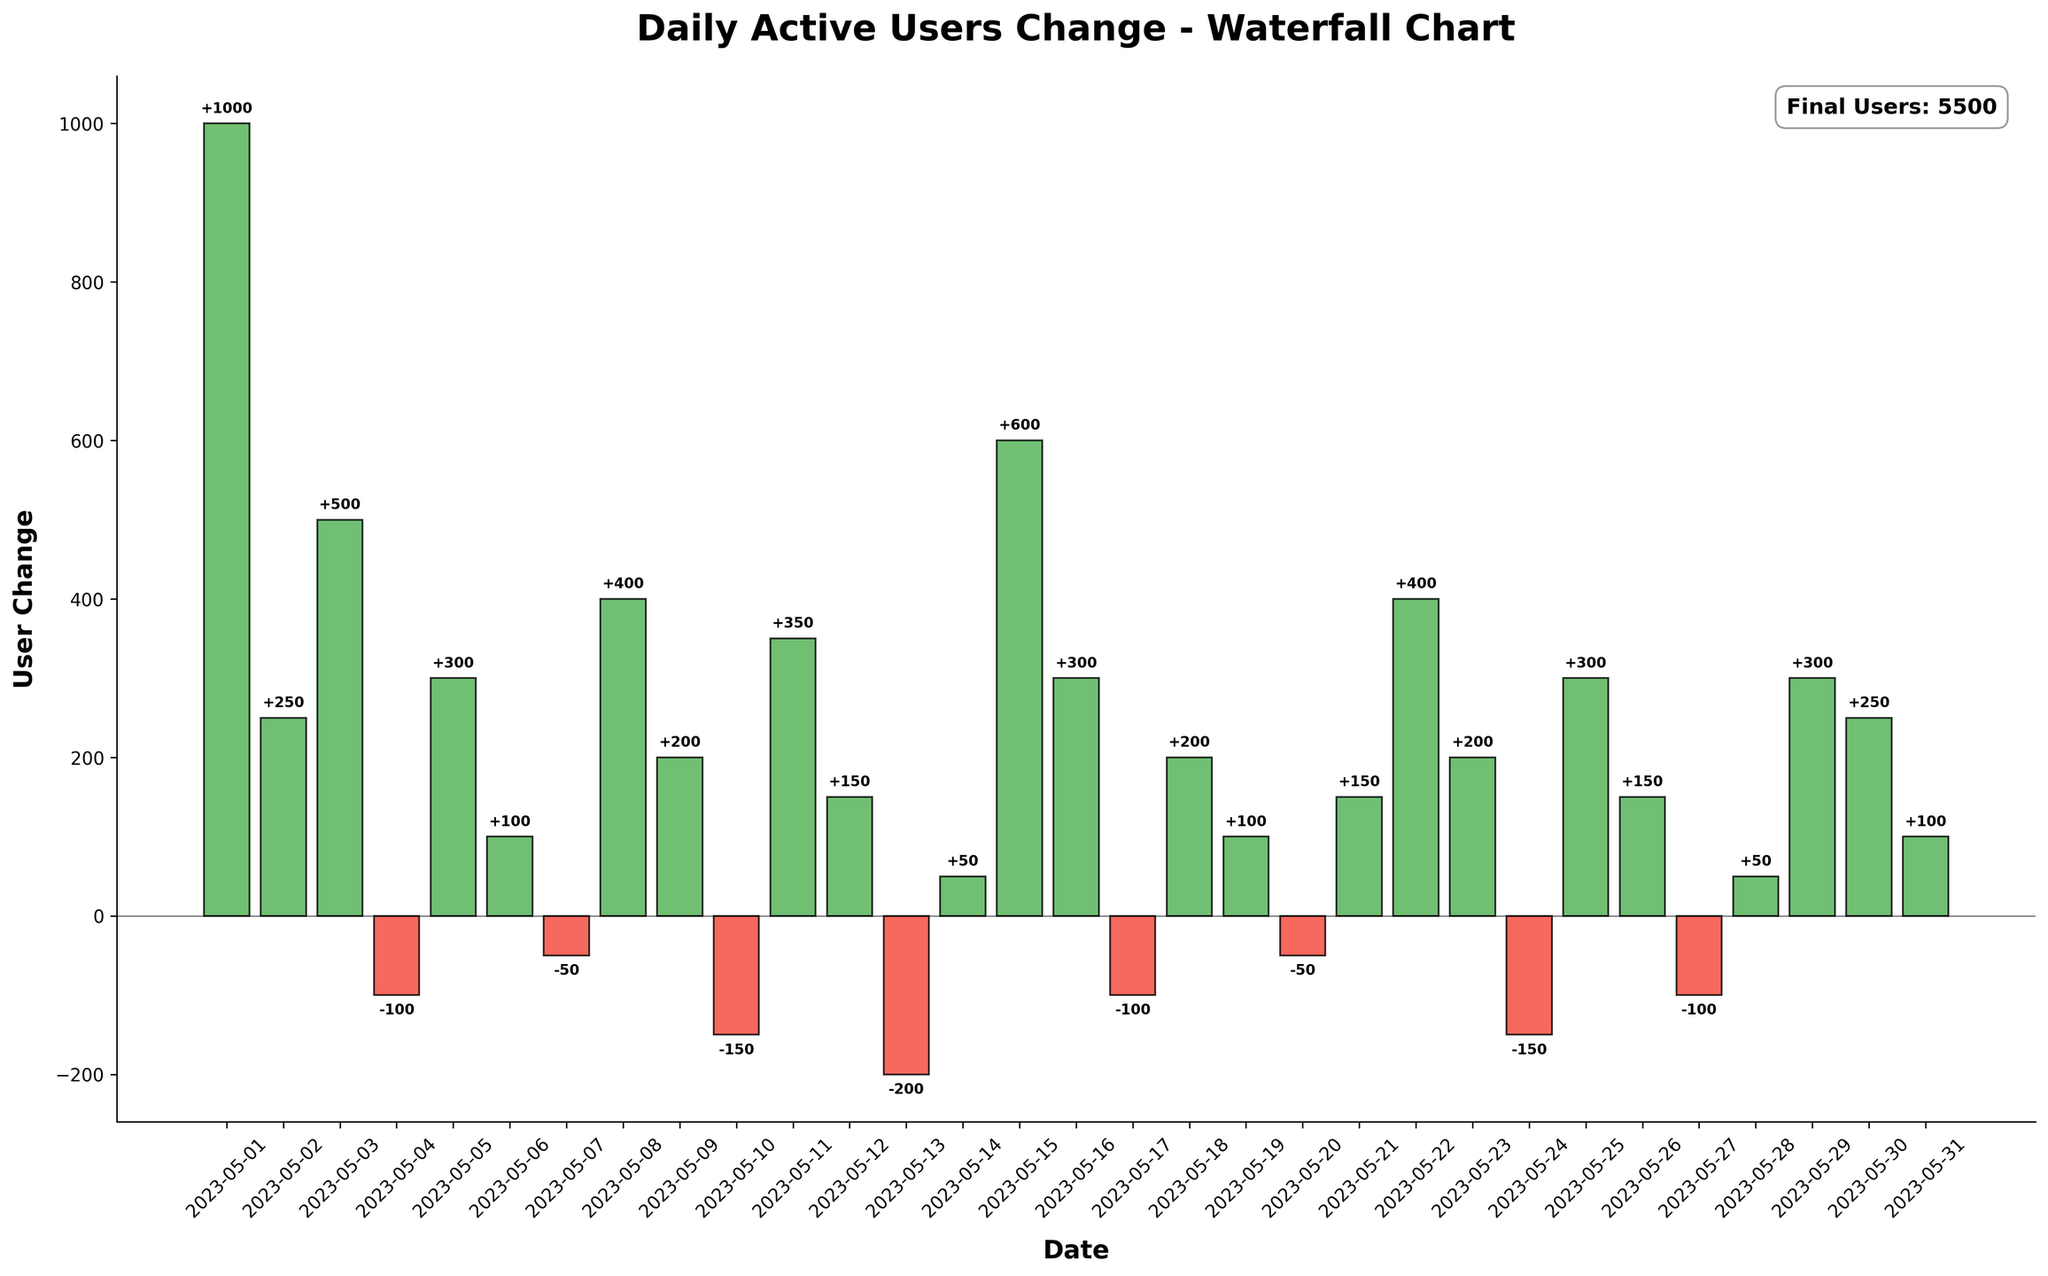what is the title of the figure? The title of the figure is positioned at the top of the chart in large, bold font.
Answer: Daily Active Users Change - Waterfall Chart What is the total number of data points shown in the chart? Count the number of bars present in the chart, one for each day. There are 31 days shown, so 31 data points.
Answer: 31 On which date was there the highest user increase, and what was the value? Scan through the values presented above each positive bar for each date and identify the highest one. The highest positive change occurred on May 15 with an increase of 600 users.
Answer: May 15, +600 How many days had a decrease in daily active users? Count the bars with negative values (displayed in red). There are 7 days with a negative user change: May 4, May 7, May 10, May 13, May 17, May 20, May 24, and May 27.
Answer: 7 What’s the cumulative number of users on the last day represented in the chart? Look at the top-right annotation which indicates the final number of users.
Answer: 5500 What is the combined user change over the first week? Sum the daily user changes from May 1 to May 7: 1000 + 250 + 500 - 100 + 300 + 100 - 50 = 2000 users.
Answer: 2000 What is the average daily user change for the month? Sum all the daily changes and divide by the number of days (31). The sum of changes is 1000 + 250 + 500 - 100 + 300 + 100 - 50 + 400 + 200 - 150 + 350 + 150 - 200 + 50 + 600 + 300 - 100 + 200 + 100 - 50 + 150 + 400 + 200 - 150 + 300 + 150 - 100 + 50 + 300 + 250 + 100 = 5300. The average is 5300 / 31 = ~171.
Answer: ~171 Which day experienced the largest drop in user engagement? Identify the bar with the lowest value. The largest drop was on May 13, with a decrease of -200 users.
Answer: May 13, -200 How did the user engagement change on May 8? Refer to the bar for May 8 and check its value; it shows a user change of +400.
Answer: +400 